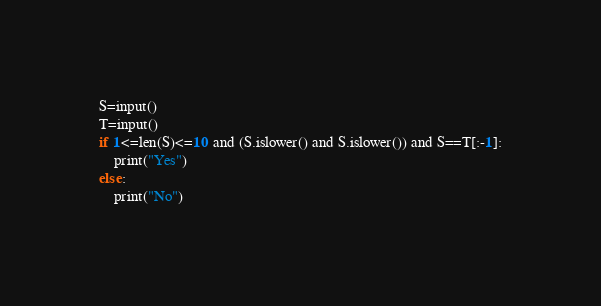<code> <loc_0><loc_0><loc_500><loc_500><_Python_>S=input()
T=input()
if 1<=len(S)<=10 and (S.islower() and S.islower()) and S==T[:-1]:
    print("Yes")
else:
    print("No")</code> 